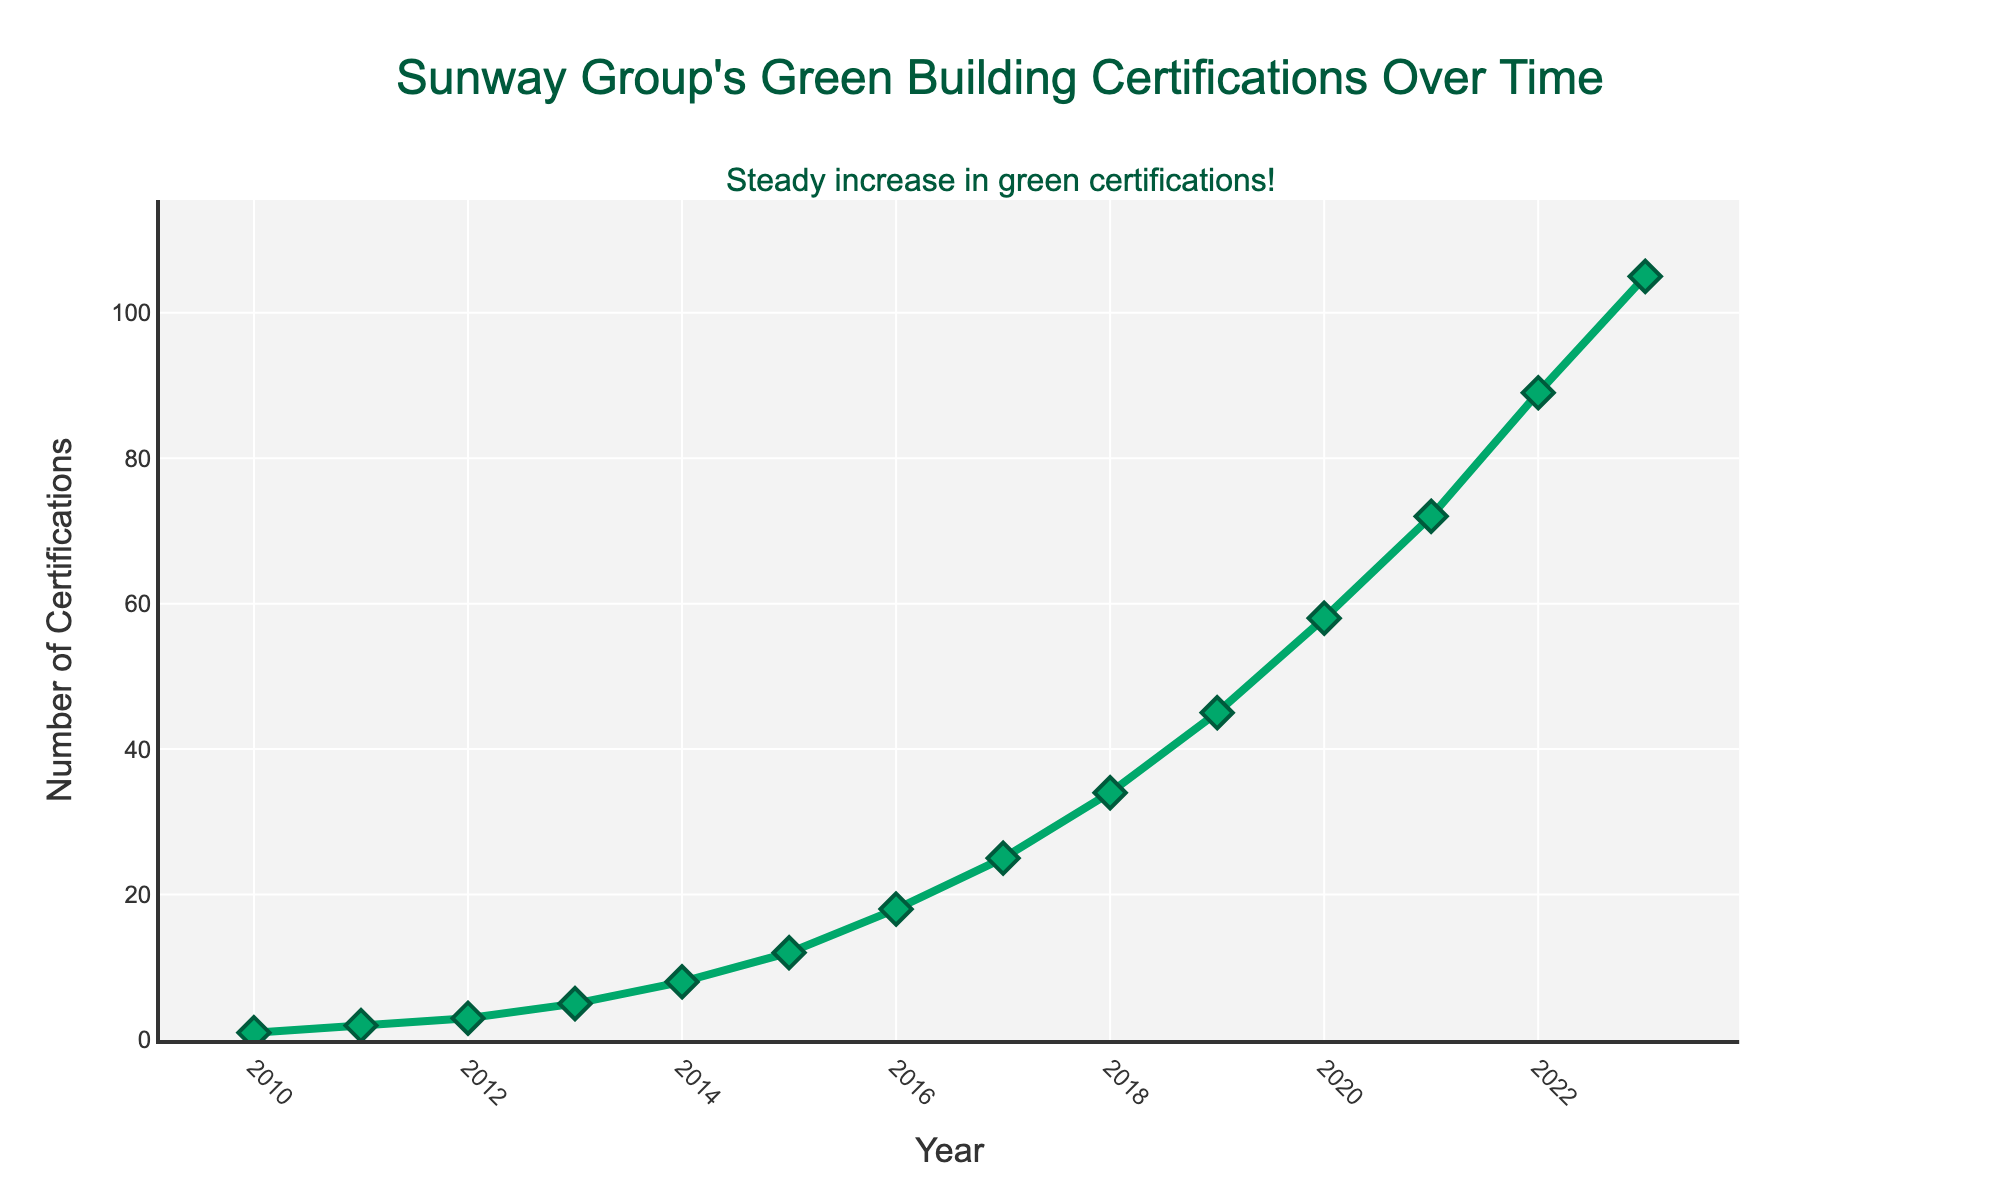What was the number of green building certifications achieved by Sunway in 2015? Locate the year 2015 on the x-axis and check the corresponding y-value, which gives the number of certifications.
Answer: 12 By how many certifications did the number increase from 2012 to 2013? Find the values for the years 2012 and 2013, which are 3 and 5 respectively. Calculate the difference: 5 - 3 = 2.
Answer: 2 What is the average number of certifications achieved annually from 2010 to 2023? Sum the values for all the years from 2010 to 2023 and divide by the number of years. Sum = 1 + 2 + 3 + 5 + 8 + 12 + 18 + 25 + 34 + 45 + 58 + 72 + 89 + 105 = 477. Number of years = 2023 - 2010 + 1 = 14. Average = 477 / 14 ≈ 34.07.
Answer: 34.07 Which year saw the highest number of green building certifications? Identify the highest value on the y-axis and find the corresponding year on the x-axis. The highest value is 105 in 2023.
Answer: 2023 By what percentage did the number of certifications increase from 2019 to 2020? Find the values for 2019 and 2020, which are 45 and 58 respectively. Calculate the percentage increase: ((58 - 45) / 45) * 100 = 28.89%.
Answer: 28.89% In which years did the number of certifications more than double compared to the previous year? Compare each year's value to the previous year's value and identify where the current value is more than double the previous value. No years meet this condition in the dataset.
Answer: None What trend does the line chart show for the green building certifications achieved by Sunway from 2010 to 2023? The line chart shows a steep increasing trend from 2010 to 2023, indicating rapid growth in the number of green building certifications achieved by Sunway.
Answer: Increasing Between which two consecutive years did Sunway achieve the largest increase in green building certifications? Calculate the difference for each consecutive year and find the maximum difference. The largest increase is from 2022 (89) to 2023 (105), which is 16.
Answer: 2022 to 2023 During which year did Sunway achieve exactly 25 certifications? Locate the value of 25 on the y-axis and find the corresponding year on the x-axis, which is 2017.
Answer: 2017 What is the overall growth in the number of certifications from 2010 to 2023? Subtract the number of certifications in 2010 from the number in 2023: 105 - 1 = 104.
Answer: 104 